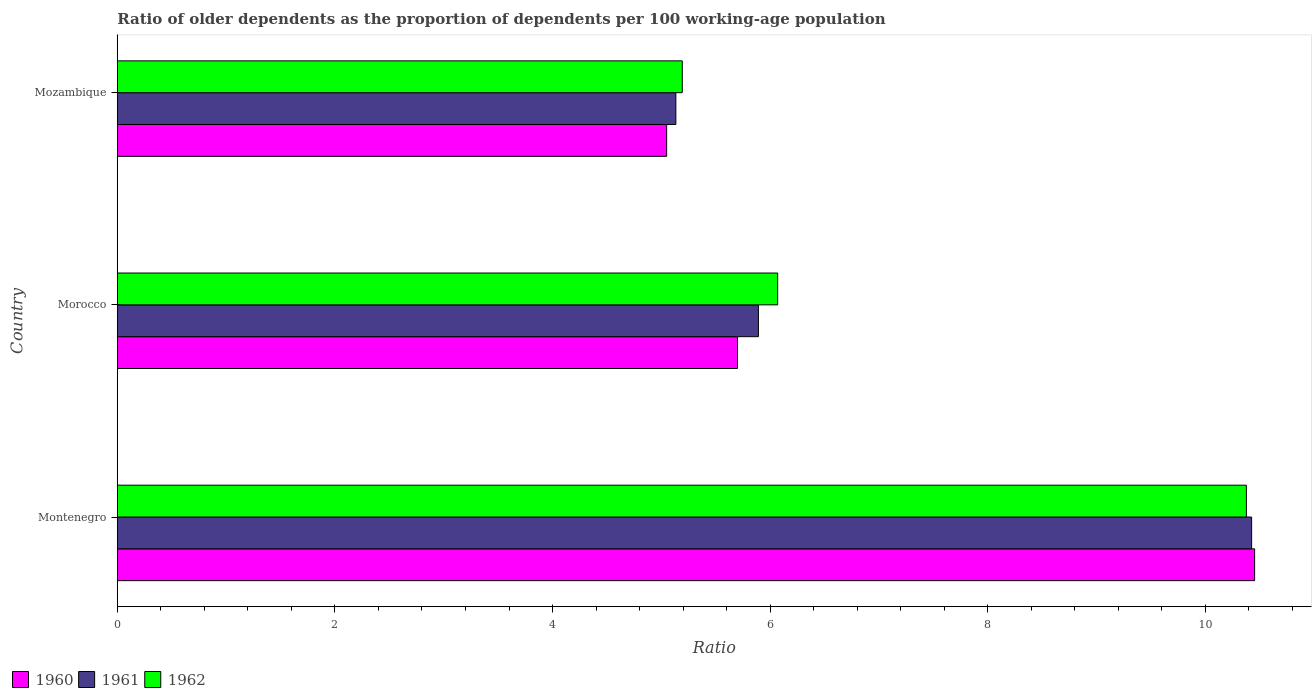How many different coloured bars are there?
Make the answer very short. 3. How many groups of bars are there?
Your answer should be very brief. 3. Are the number of bars per tick equal to the number of legend labels?
Make the answer very short. Yes. How many bars are there on the 3rd tick from the top?
Give a very brief answer. 3. How many bars are there on the 3rd tick from the bottom?
Your answer should be very brief. 3. What is the label of the 3rd group of bars from the top?
Provide a short and direct response. Montenegro. In how many cases, is the number of bars for a given country not equal to the number of legend labels?
Provide a short and direct response. 0. What is the age dependency ratio(old) in 1962 in Montenegro?
Provide a short and direct response. 10.38. Across all countries, what is the maximum age dependency ratio(old) in 1961?
Ensure brevity in your answer.  10.42. Across all countries, what is the minimum age dependency ratio(old) in 1961?
Provide a short and direct response. 5.13. In which country was the age dependency ratio(old) in 1962 maximum?
Ensure brevity in your answer.  Montenegro. In which country was the age dependency ratio(old) in 1960 minimum?
Your answer should be compact. Mozambique. What is the total age dependency ratio(old) in 1960 in the graph?
Keep it short and to the point. 21.2. What is the difference between the age dependency ratio(old) in 1961 in Morocco and that in Mozambique?
Ensure brevity in your answer.  0.76. What is the difference between the age dependency ratio(old) in 1960 in Morocco and the age dependency ratio(old) in 1961 in Mozambique?
Your answer should be compact. 0.57. What is the average age dependency ratio(old) in 1961 per country?
Ensure brevity in your answer.  7.15. What is the difference between the age dependency ratio(old) in 1960 and age dependency ratio(old) in 1962 in Mozambique?
Offer a terse response. -0.14. In how many countries, is the age dependency ratio(old) in 1961 greater than 6 ?
Make the answer very short. 1. What is the ratio of the age dependency ratio(old) in 1960 in Montenegro to that in Mozambique?
Ensure brevity in your answer.  2.07. Is the age dependency ratio(old) in 1960 in Montenegro less than that in Mozambique?
Your response must be concise. No. What is the difference between the highest and the second highest age dependency ratio(old) in 1961?
Offer a terse response. 4.53. What is the difference between the highest and the lowest age dependency ratio(old) in 1962?
Make the answer very short. 5.18. What does the 3rd bar from the bottom in Montenegro represents?
Provide a short and direct response. 1962. Is it the case that in every country, the sum of the age dependency ratio(old) in 1961 and age dependency ratio(old) in 1962 is greater than the age dependency ratio(old) in 1960?
Keep it short and to the point. Yes. How many countries are there in the graph?
Give a very brief answer. 3. What is the difference between two consecutive major ticks on the X-axis?
Provide a succinct answer. 2. How are the legend labels stacked?
Your answer should be compact. Horizontal. What is the title of the graph?
Provide a short and direct response. Ratio of older dependents as the proportion of dependents per 100 working-age population. What is the label or title of the X-axis?
Provide a succinct answer. Ratio. What is the Ratio in 1960 in Montenegro?
Your response must be concise. 10.45. What is the Ratio of 1961 in Montenegro?
Provide a succinct answer. 10.42. What is the Ratio of 1962 in Montenegro?
Offer a very short reply. 10.38. What is the Ratio in 1960 in Morocco?
Give a very brief answer. 5.7. What is the Ratio in 1961 in Morocco?
Offer a terse response. 5.89. What is the Ratio in 1962 in Morocco?
Offer a terse response. 6.07. What is the Ratio of 1960 in Mozambique?
Your answer should be compact. 5.05. What is the Ratio of 1961 in Mozambique?
Ensure brevity in your answer.  5.13. What is the Ratio of 1962 in Mozambique?
Make the answer very short. 5.19. Across all countries, what is the maximum Ratio of 1960?
Offer a terse response. 10.45. Across all countries, what is the maximum Ratio of 1961?
Keep it short and to the point. 10.42. Across all countries, what is the maximum Ratio of 1962?
Your answer should be compact. 10.38. Across all countries, what is the minimum Ratio in 1960?
Ensure brevity in your answer.  5.05. Across all countries, what is the minimum Ratio of 1961?
Ensure brevity in your answer.  5.13. Across all countries, what is the minimum Ratio of 1962?
Offer a terse response. 5.19. What is the total Ratio in 1960 in the graph?
Your response must be concise. 21.2. What is the total Ratio of 1961 in the graph?
Ensure brevity in your answer.  21.45. What is the total Ratio in 1962 in the graph?
Provide a short and direct response. 21.64. What is the difference between the Ratio in 1960 in Montenegro and that in Morocco?
Ensure brevity in your answer.  4.75. What is the difference between the Ratio in 1961 in Montenegro and that in Morocco?
Offer a terse response. 4.53. What is the difference between the Ratio of 1962 in Montenegro and that in Morocco?
Provide a short and direct response. 4.31. What is the difference between the Ratio of 1960 in Montenegro and that in Mozambique?
Your response must be concise. 5.4. What is the difference between the Ratio of 1961 in Montenegro and that in Mozambique?
Offer a terse response. 5.29. What is the difference between the Ratio of 1962 in Montenegro and that in Mozambique?
Make the answer very short. 5.18. What is the difference between the Ratio of 1960 in Morocco and that in Mozambique?
Your answer should be compact. 0.65. What is the difference between the Ratio in 1961 in Morocco and that in Mozambique?
Keep it short and to the point. 0.76. What is the difference between the Ratio in 1962 in Morocco and that in Mozambique?
Offer a very short reply. 0.88. What is the difference between the Ratio in 1960 in Montenegro and the Ratio in 1961 in Morocco?
Give a very brief answer. 4.56. What is the difference between the Ratio of 1960 in Montenegro and the Ratio of 1962 in Morocco?
Your answer should be compact. 4.38. What is the difference between the Ratio in 1961 in Montenegro and the Ratio in 1962 in Morocco?
Ensure brevity in your answer.  4.36. What is the difference between the Ratio of 1960 in Montenegro and the Ratio of 1961 in Mozambique?
Give a very brief answer. 5.32. What is the difference between the Ratio in 1960 in Montenegro and the Ratio in 1962 in Mozambique?
Provide a succinct answer. 5.26. What is the difference between the Ratio in 1961 in Montenegro and the Ratio in 1962 in Mozambique?
Your answer should be very brief. 5.23. What is the difference between the Ratio of 1960 in Morocco and the Ratio of 1961 in Mozambique?
Ensure brevity in your answer.  0.57. What is the difference between the Ratio in 1960 in Morocco and the Ratio in 1962 in Mozambique?
Offer a terse response. 0.51. What is the difference between the Ratio in 1961 in Morocco and the Ratio in 1962 in Mozambique?
Provide a succinct answer. 0.7. What is the average Ratio in 1960 per country?
Your answer should be compact. 7.07. What is the average Ratio in 1961 per country?
Offer a very short reply. 7.15. What is the average Ratio of 1962 per country?
Your response must be concise. 7.21. What is the difference between the Ratio of 1960 and Ratio of 1961 in Montenegro?
Your answer should be compact. 0.03. What is the difference between the Ratio in 1960 and Ratio in 1962 in Montenegro?
Make the answer very short. 0.08. What is the difference between the Ratio of 1961 and Ratio of 1962 in Montenegro?
Offer a very short reply. 0.05. What is the difference between the Ratio in 1960 and Ratio in 1961 in Morocco?
Make the answer very short. -0.19. What is the difference between the Ratio of 1960 and Ratio of 1962 in Morocco?
Your response must be concise. -0.37. What is the difference between the Ratio in 1961 and Ratio in 1962 in Morocco?
Keep it short and to the point. -0.18. What is the difference between the Ratio of 1960 and Ratio of 1961 in Mozambique?
Your response must be concise. -0.08. What is the difference between the Ratio in 1960 and Ratio in 1962 in Mozambique?
Offer a terse response. -0.14. What is the difference between the Ratio of 1961 and Ratio of 1962 in Mozambique?
Provide a succinct answer. -0.06. What is the ratio of the Ratio of 1960 in Montenegro to that in Morocco?
Make the answer very short. 1.83. What is the ratio of the Ratio of 1961 in Montenegro to that in Morocco?
Give a very brief answer. 1.77. What is the ratio of the Ratio of 1962 in Montenegro to that in Morocco?
Your answer should be very brief. 1.71. What is the ratio of the Ratio in 1960 in Montenegro to that in Mozambique?
Your answer should be compact. 2.07. What is the ratio of the Ratio in 1961 in Montenegro to that in Mozambique?
Provide a succinct answer. 2.03. What is the ratio of the Ratio in 1962 in Montenegro to that in Mozambique?
Give a very brief answer. 2. What is the ratio of the Ratio of 1960 in Morocco to that in Mozambique?
Keep it short and to the point. 1.13. What is the ratio of the Ratio in 1961 in Morocco to that in Mozambique?
Your answer should be very brief. 1.15. What is the ratio of the Ratio in 1962 in Morocco to that in Mozambique?
Keep it short and to the point. 1.17. What is the difference between the highest and the second highest Ratio of 1960?
Make the answer very short. 4.75. What is the difference between the highest and the second highest Ratio in 1961?
Ensure brevity in your answer.  4.53. What is the difference between the highest and the second highest Ratio in 1962?
Offer a very short reply. 4.31. What is the difference between the highest and the lowest Ratio in 1960?
Give a very brief answer. 5.4. What is the difference between the highest and the lowest Ratio of 1961?
Ensure brevity in your answer.  5.29. What is the difference between the highest and the lowest Ratio of 1962?
Provide a succinct answer. 5.18. 